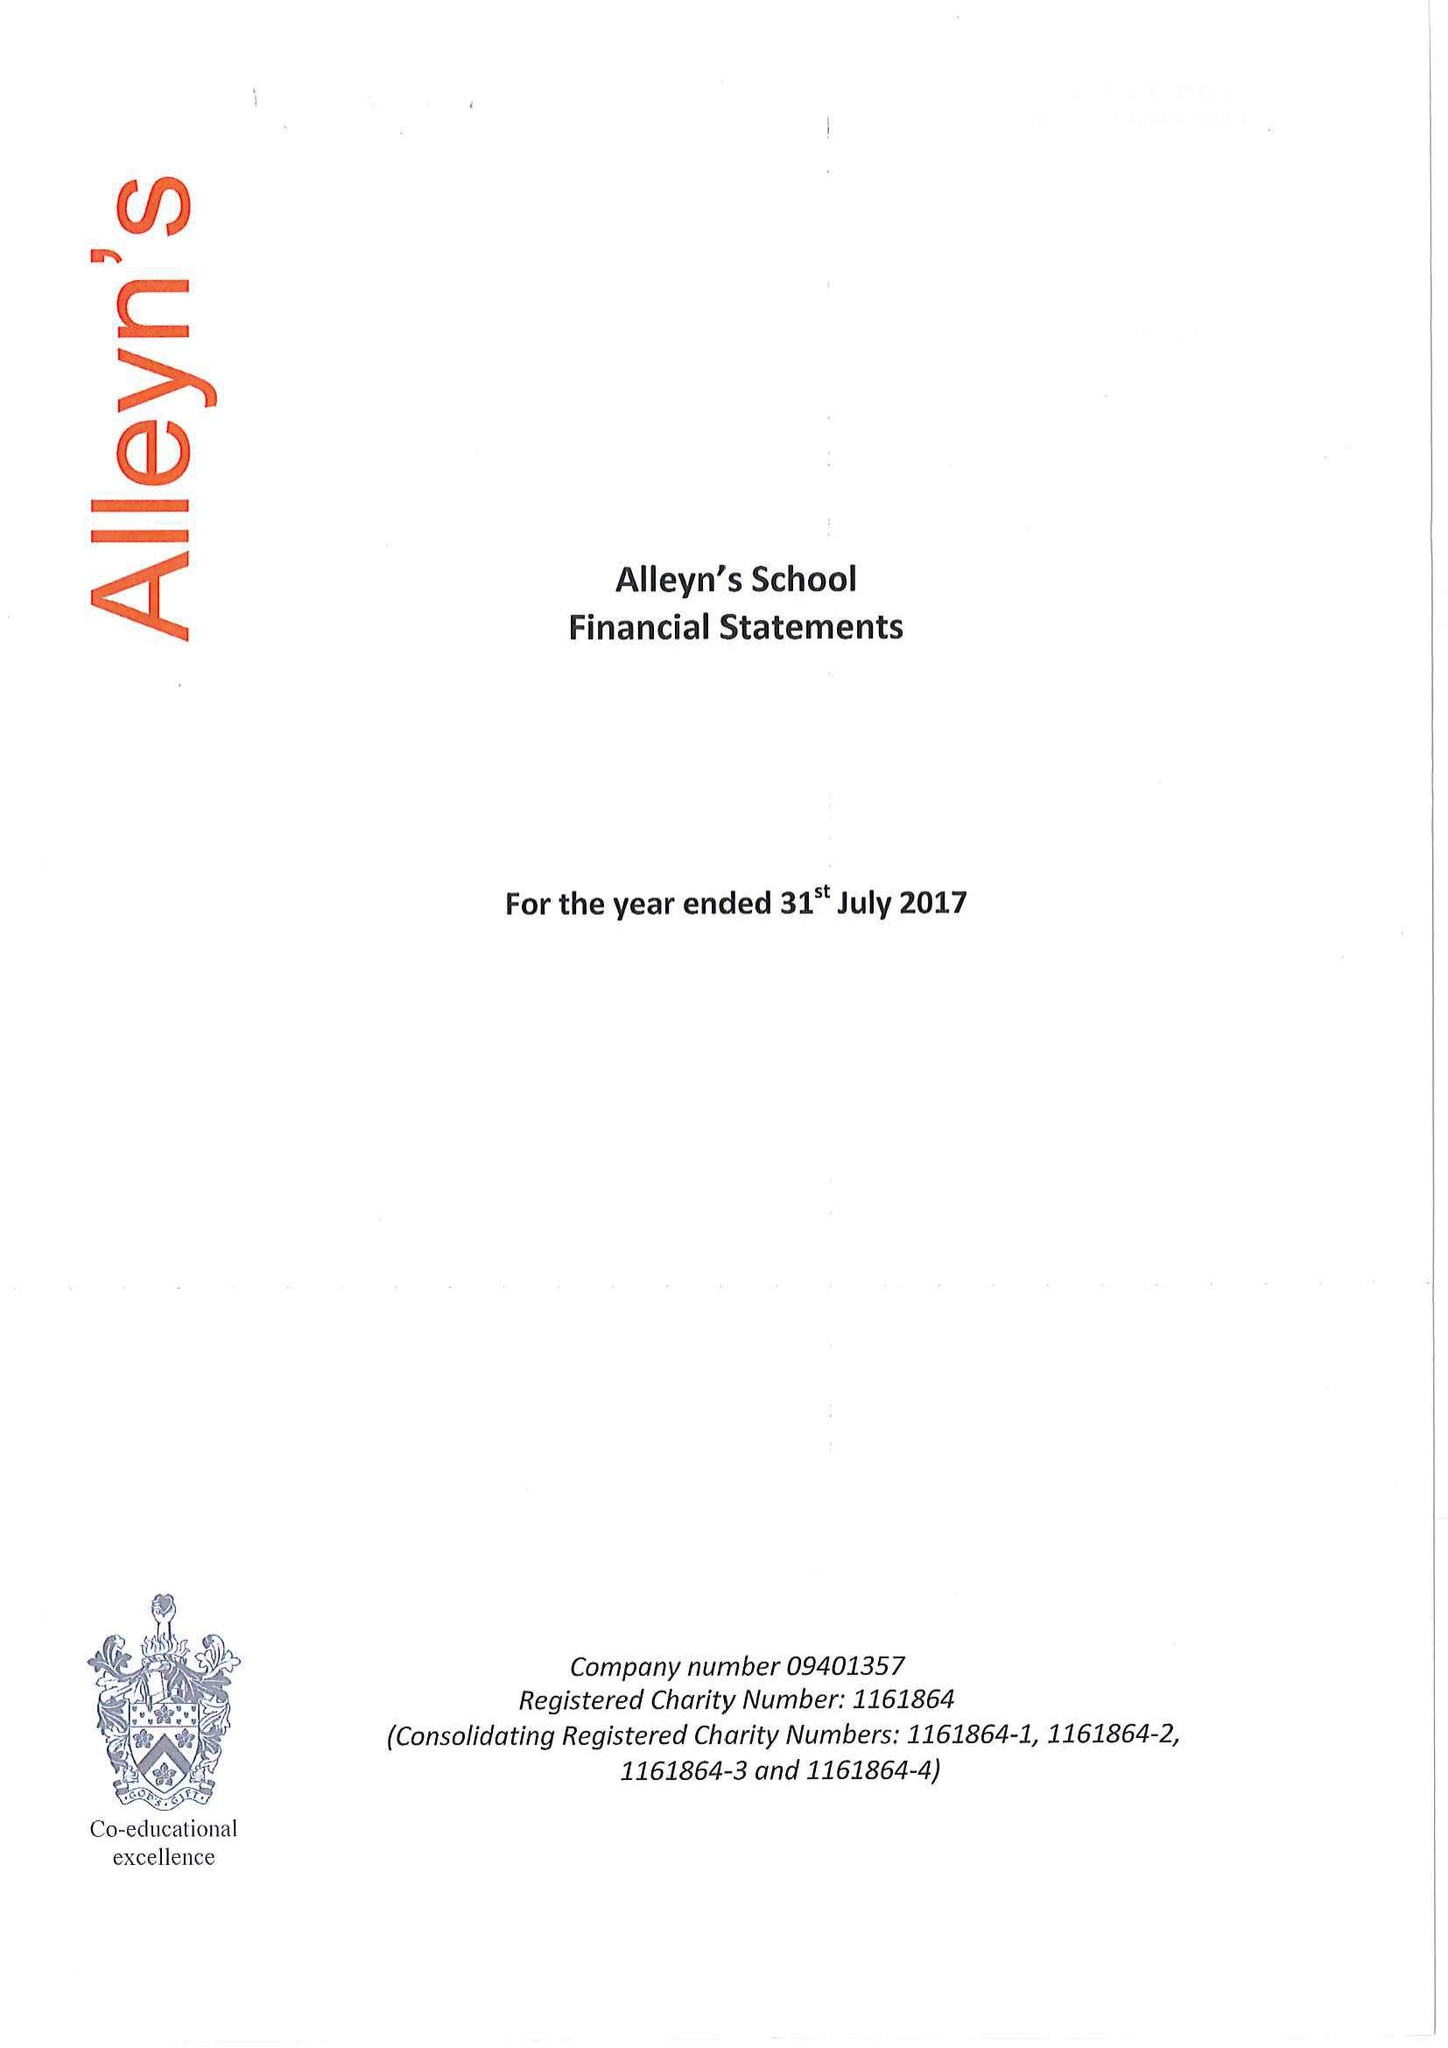What is the value for the spending_annually_in_british_pounds?
Answer the question using a single word or phrase. 22765000.00 